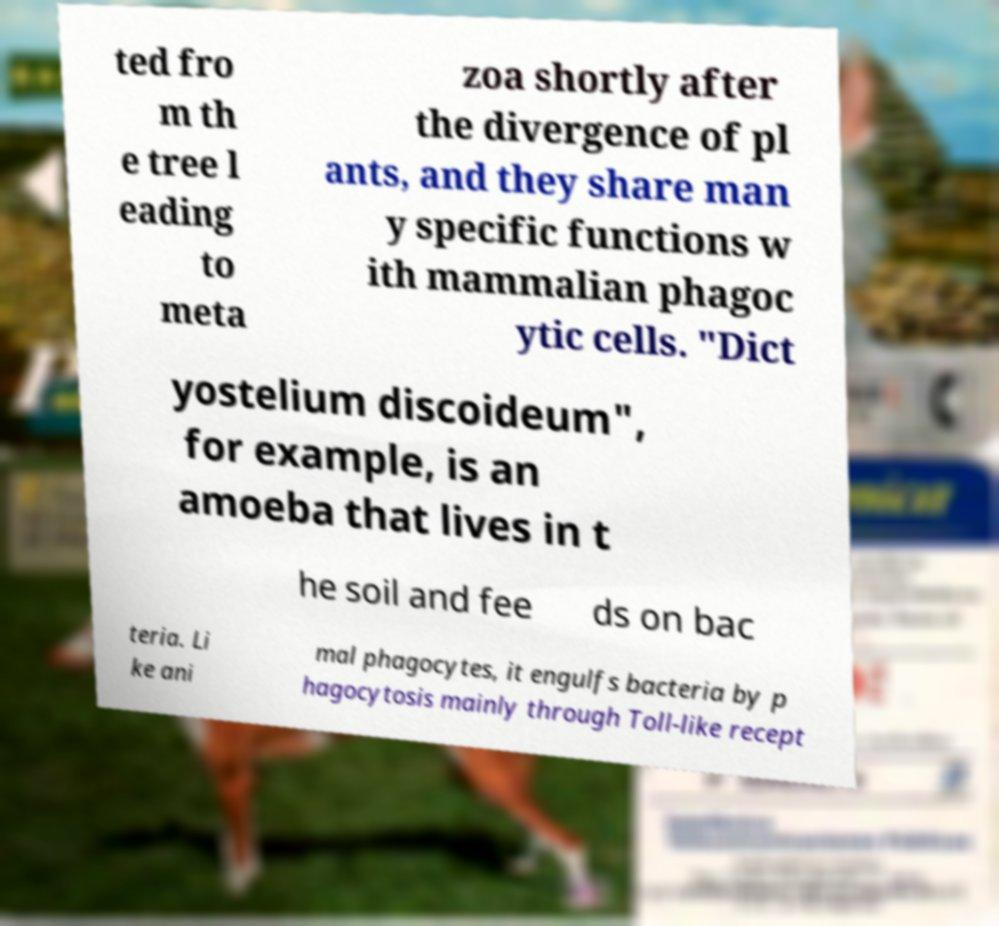Could you assist in decoding the text presented in this image and type it out clearly? ted fro m th e tree l eading to meta zoa shortly after the divergence of pl ants, and they share man y specific functions w ith mammalian phagoc ytic cells. "Dict yostelium discoideum", for example, is an amoeba that lives in t he soil and fee ds on bac teria. Li ke ani mal phagocytes, it engulfs bacteria by p hagocytosis mainly through Toll-like recept 